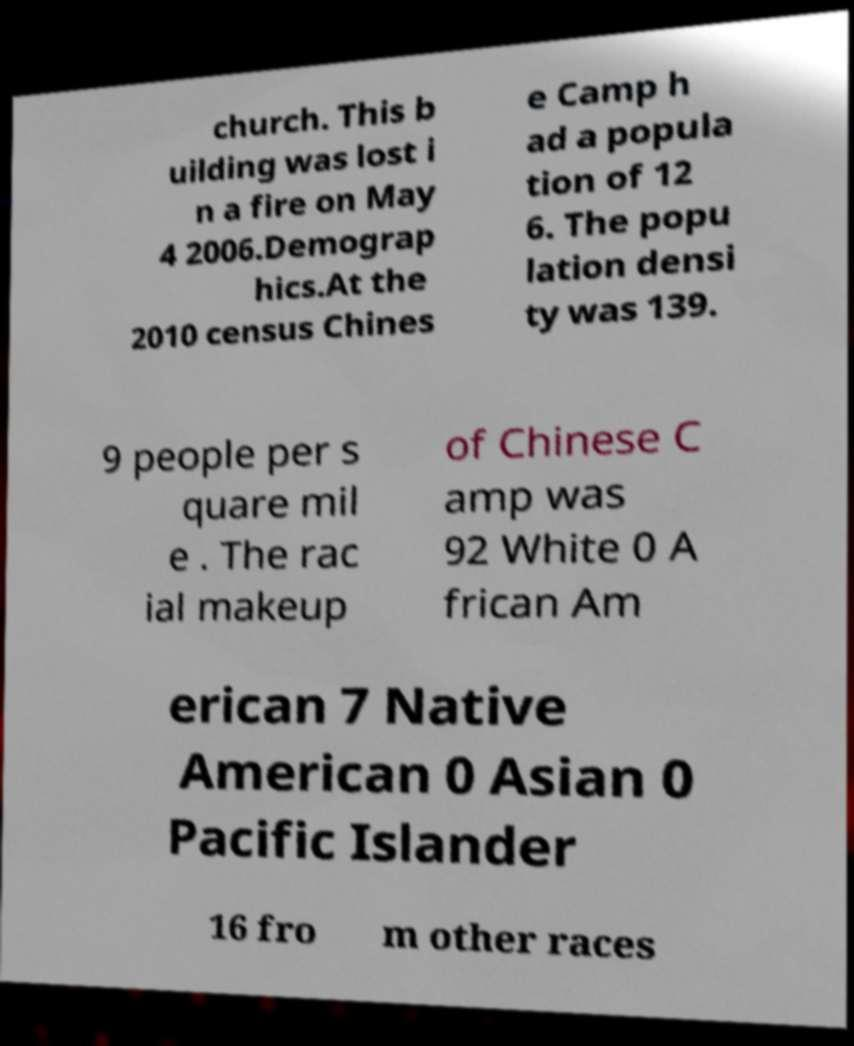Please identify and transcribe the text found in this image. church. This b uilding was lost i n a fire on May 4 2006.Demograp hics.At the 2010 census Chines e Camp h ad a popula tion of 12 6. The popu lation densi ty was 139. 9 people per s quare mil e . The rac ial makeup of Chinese C amp was 92 White 0 A frican Am erican 7 Native American 0 Asian 0 Pacific Islander 16 fro m other races 